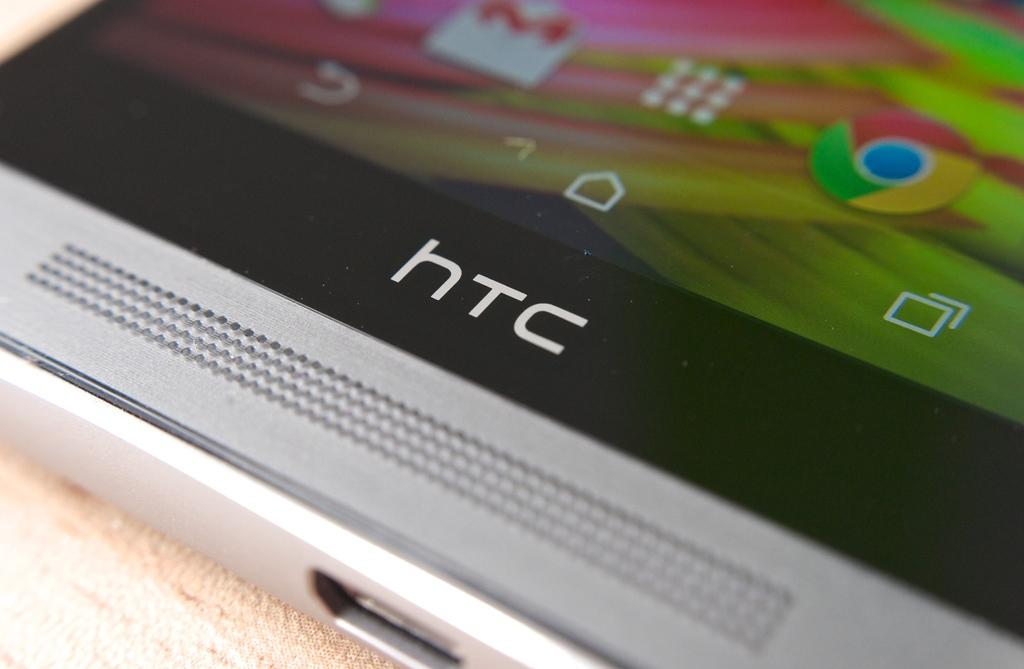<image>
Render a clear and concise summary of the photo. The bottom of a device from the company htc 